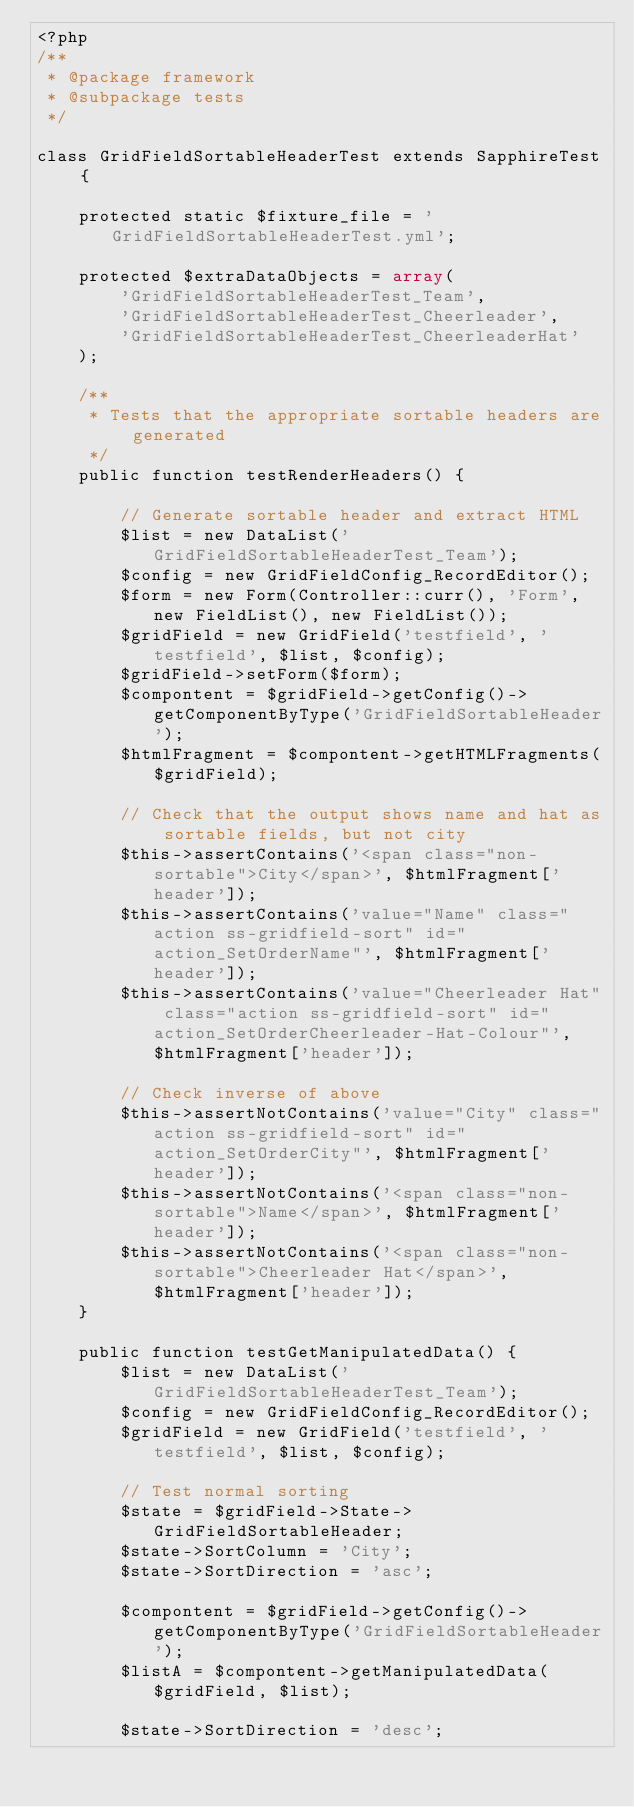Convert code to text. <code><loc_0><loc_0><loc_500><loc_500><_PHP_><?php
/**
 * @package framework
 * @subpackage tests
 */

class GridFieldSortableHeaderTest extends SapphireTest {

	protected static $fixture_file = 'GridFieldSortableHeaderTest.yml';

	protected $extraDataObjects = array(
		'GridFieldSortableHeaderTest_Team',
		'GridFieldSortableHeaderTest_Cheerleader',
		'GridFieldSortableHeaderTest_CheerleaderHat'
	);
	
	/**
	 * Tests that the appropriate sortable headers are generated
	 */
	public function testRenderHeaders() {
		
		// Generate sortable header and extract HTML
		$list = new DataList('GridFieldSortableHeaderTest_Team');
		$config = new GridFieldConfig_RecordEditor();
		$form = new Form(Controller::curr(), 'Form', new FieldList(), new FieldList());
		$gridField = new GridField('testfield', 'testfield', $list, $config);
		$gridField->setForm($form);
		$compontent = $gridField->getConfig()->getComponentByType('GridFieldSortableHeader');
		$htmlFragment = $compontent->getHTMLFragments($gridField);
		
		// Check that the output shows name and hat as sortable fields, but not city
		$this->assertContains('<span class="non-sortable">City</span>', $htmlFragment['header']);
		$this->assertContains('value="Name" class="action ss-gridfield-sort" id="action_SetOrderName"', $htmlFragment['header']);
		$this->assertContains('value="Cheerleader Hat" class="action ss-gridfield-sort" id="action_SetOrderCheerleader-Hat-Colour"', $htmlFragment['header']);
		
		// Check inverse of above
		$this->assertNotContains('value="City" class="action ss-gridfield-sort" id="action_SetOrderCity"', $htmlFragment['header']);
		$this->assertNotContains('<span class="non-sortable">Name</span>', $htmlFragment['header']);
		$this->assertNotContains('<span class="non-sortable">Cheerleader Hat</span>', $htmlFragment['header']);
	}

	public function testGetManipulatedData() {
		$list = new DataList('GridFieldSortableHeaderTest_Team');
		$config = new GridFieldConfig_RecordEditor();
		$gridField = new GridField('testfield', 'testfield', $list, $config);

		// Test normal sorting
		$state = $gridField->State->GridFieldSortableHeader;
		$state->SortColumn = 'City';
		$state->SortDirection = 'asc';

		$compontent = $gridField->getConfig()->getComponentByType('GridFieldSortableHeader');
		$listA = $compontent->getManipulatedData($gridField, $list);

		$state->SortDirection = 'desc';</code> 